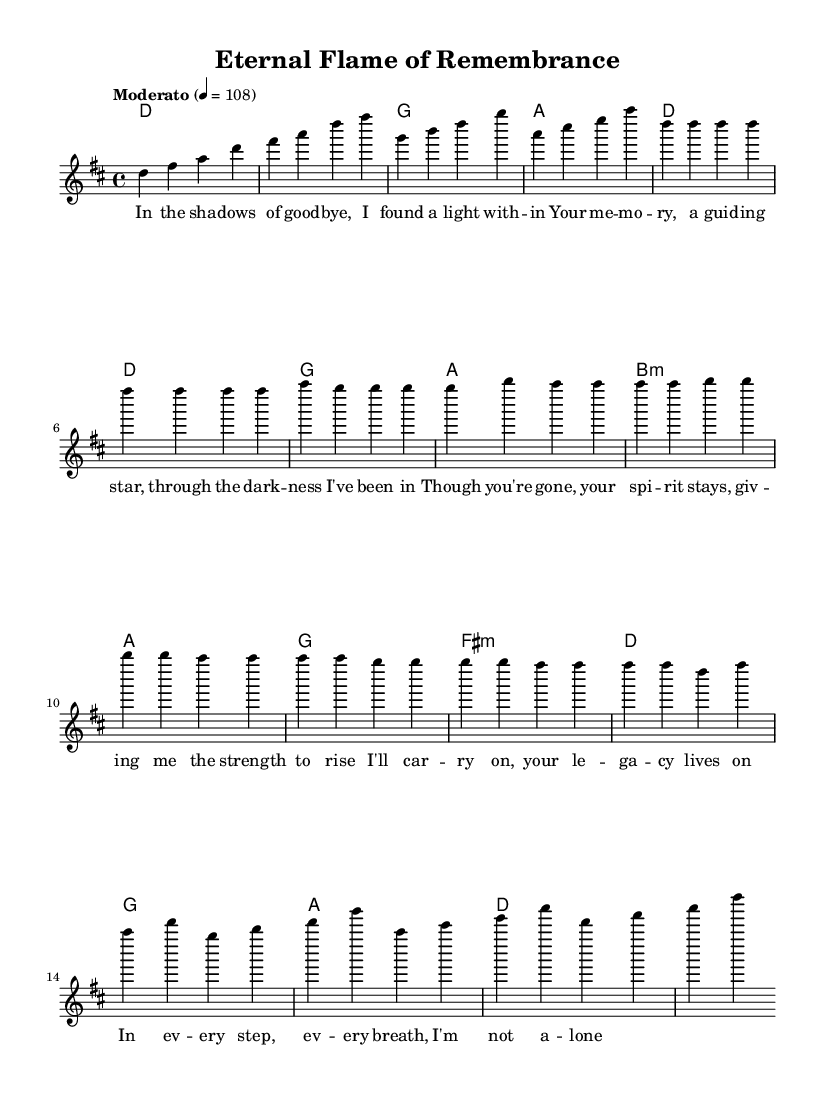What is the key signature of this music? The key signature is D major, which has two sharps, F sharp and C sharp. This can be deduced from the notation at the beginning of the score where the key is indicated.
Answer: D major What is the time signature of this music? The time signature is 4/4, meaning there are four beats in a measure, and the quarter note gets the beat. This is clearly shown at the beginning of the score next to the key signature.
Answer: 4/4 What is the tempo marking of the piece? The tempo marking is Moderato, with a metronome marking of 108 beats per minute, which indicates a moderate speed. This is stated in the score right after the time signature.
Answer: Moderato How many measures are there in the chorus? There are four measures in the chorus, which is determined by counting the measures in the section labeled as 'Chorus' in the score.
Answer: Four What chord is played in the first measure of the verse? The first measure of the verse has a D major chord, as indicated in the chord section aligned with the melody.
Answer: D major What lyrical theme can be inferred from the lyrics? The lyrics convey themes of remembrance and resilience, expressing how the memory of a loved one provides strength during difficult times. This can be inferred from the content of the lyrics provided in the score.
Answer: Remembrance and resilience Which section of the song uses the B minor chord? The B minor chord is used in the pre-chorus section, as noted in the harmonies. This can be confirmed by locating the B minor chord in the designated section of the music sheet.
Answer: Pre-Chorus 